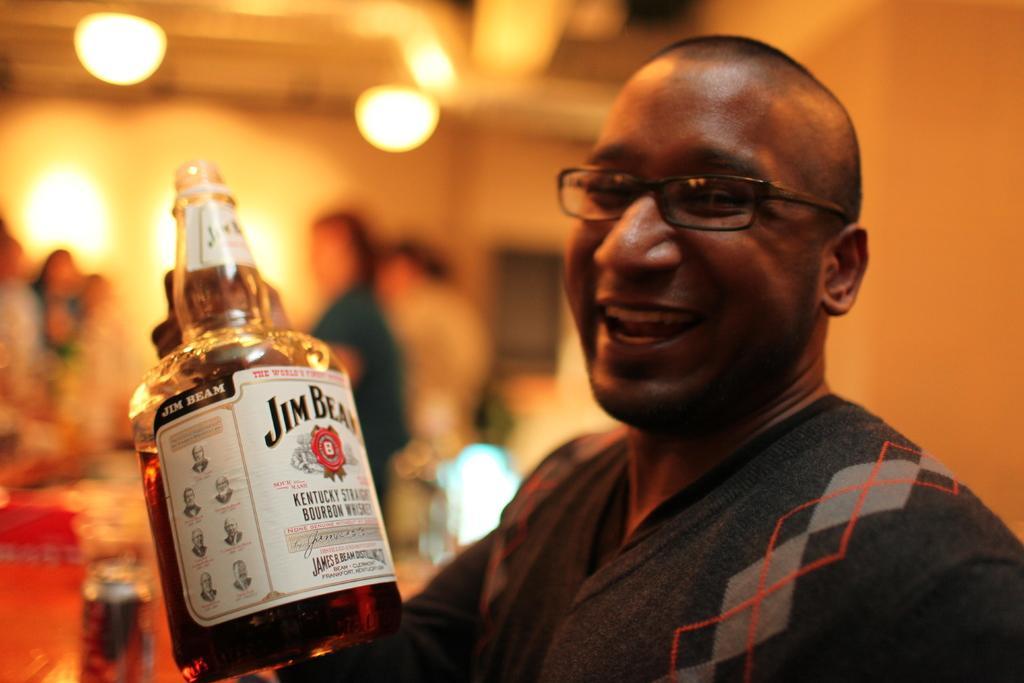Describe this image in one or two sentences. This is the picture of a guy who is wearing black color jacket is holding a bottle in his hand. 